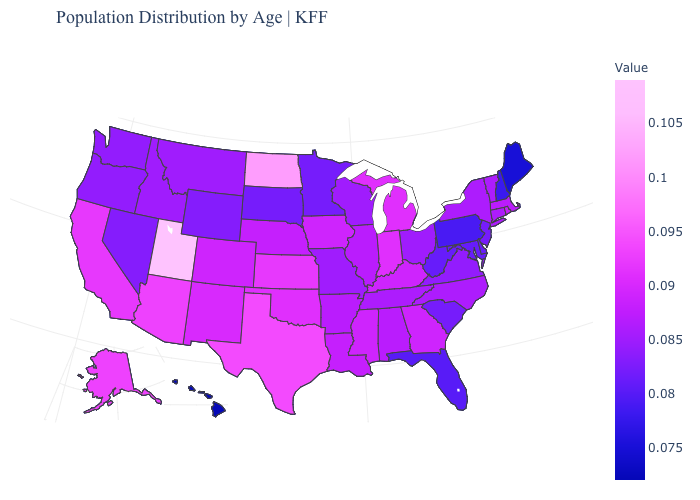Is the legend a continuous bar?
Concise answer only. Yes. Which states have the lowest value in the USA?
Write a very short answer. Hawaii. Which states hav the highest value in the West?
Write a very short answer. Utah. Does West Virginia have a higher value than Hawaii?
Keep it brief. Yes. Which states have the lowest value in the South?
Short answer required. Florida. Among the states that border Virginia , which have the lowest value?
Quick response, please. Maryland, West Virginia. Does Florida have the lowest value in the South?
Give a very brief answer. Yes. Among the states that border Idaho , which have the lowest value?
Quick response, please. Nevada, Wyoming. 